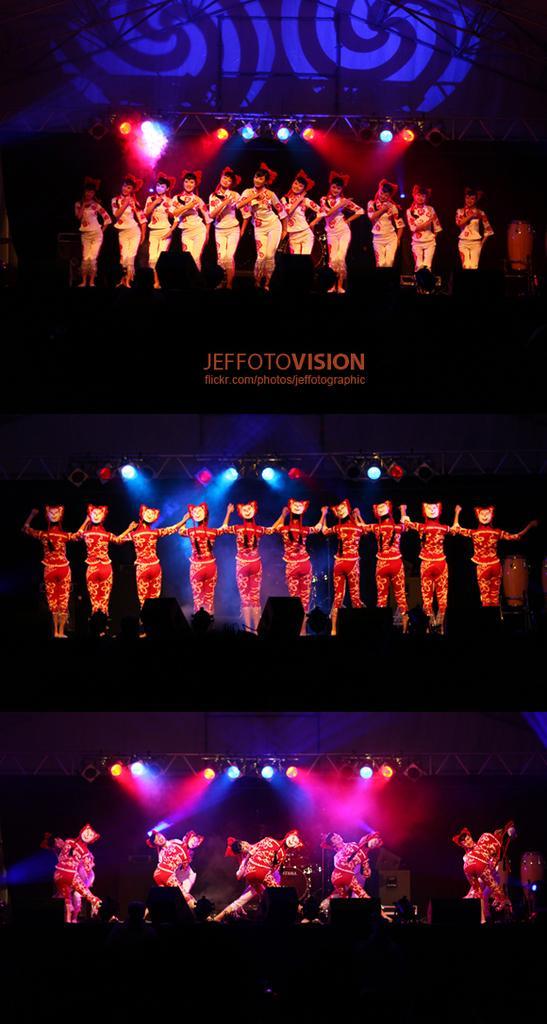Please provide a concise description of this image. In the image I can see the collage of three pictures in which there are some people who are performing on the stage and also I can see some lights and text. 